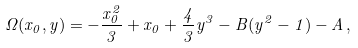<formula> <loc_0><loc_0><loc_500><loc_500>\Omega ( x _ { 0 } , y ) = - \frac { x _ { 0 } ^ { 2 } } { 3 } + x _ { 0 } + \frac { 4 } { 3 } y ^ { 3 } - B ( y ^ { 2 } - 1 ) - A \, ,</formula> 